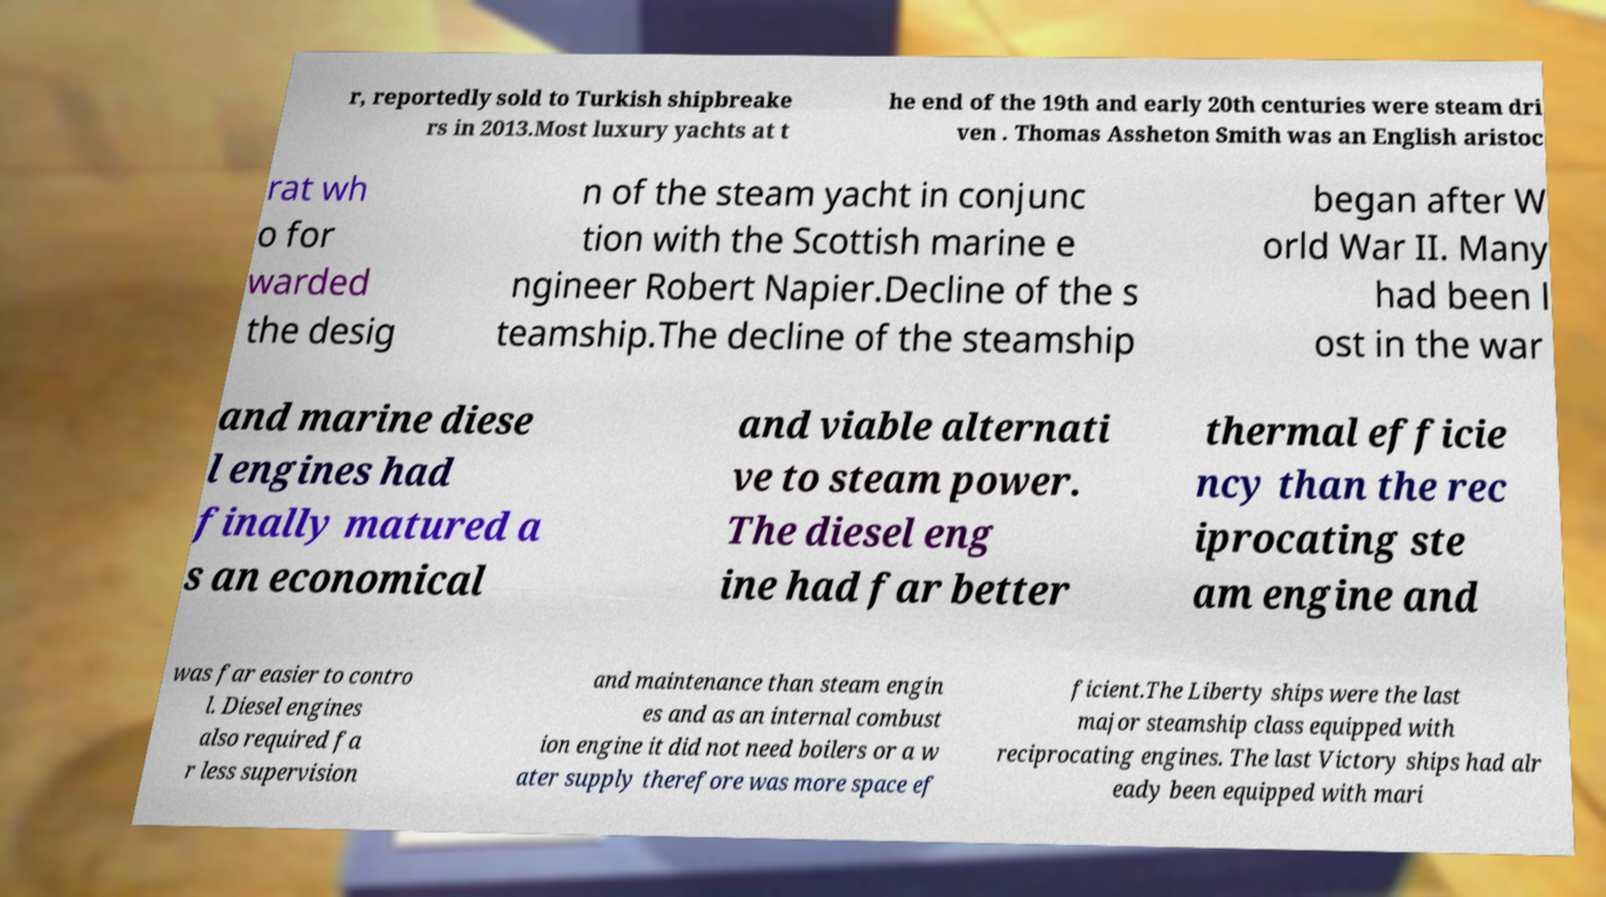There's text embedded in this image that I need extracted. Can you transcribe it verbatim? r, reportedly sold to Turkish shipbreake rs in 2013.Most luxury yachts at t he end of the 19th and early 20th centuries were steam dri ven . Thomas Assheton Smith was an English aristoc rat wh o for warded the desig n of the steam yacht in conjunc tion with the Scottish marine e ngineer Robert Napier.Decline of the s teamship.The decline of the steamship began after W orld War II. Many had been l ost in the war and marine diese l engines had finally matured a s an economical and viable alternati ve to steam power. The diesel eng ine had far better thermal efficie ncy than the rec iprocating ste am engine and was far easier to contro l. Diesel engines also required fa r less supervision and maintenance than steam engin es and as an internal combust ion engine it did not need boilers or a w ater supply therefore was more space ef ficient.The Liberty ships were the last major steamship class equipped with reciprocating engines. The last Victory ships had alr eady been equipped with mari 